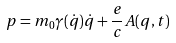Convert formula to latex. <formula><loc_0><loc_0><loc_500><loc_500>p = m _ { 0 } \gamma ( \dot { q } ) \dot { q } + \frac { e } { c } A ( q , t )</formula> 